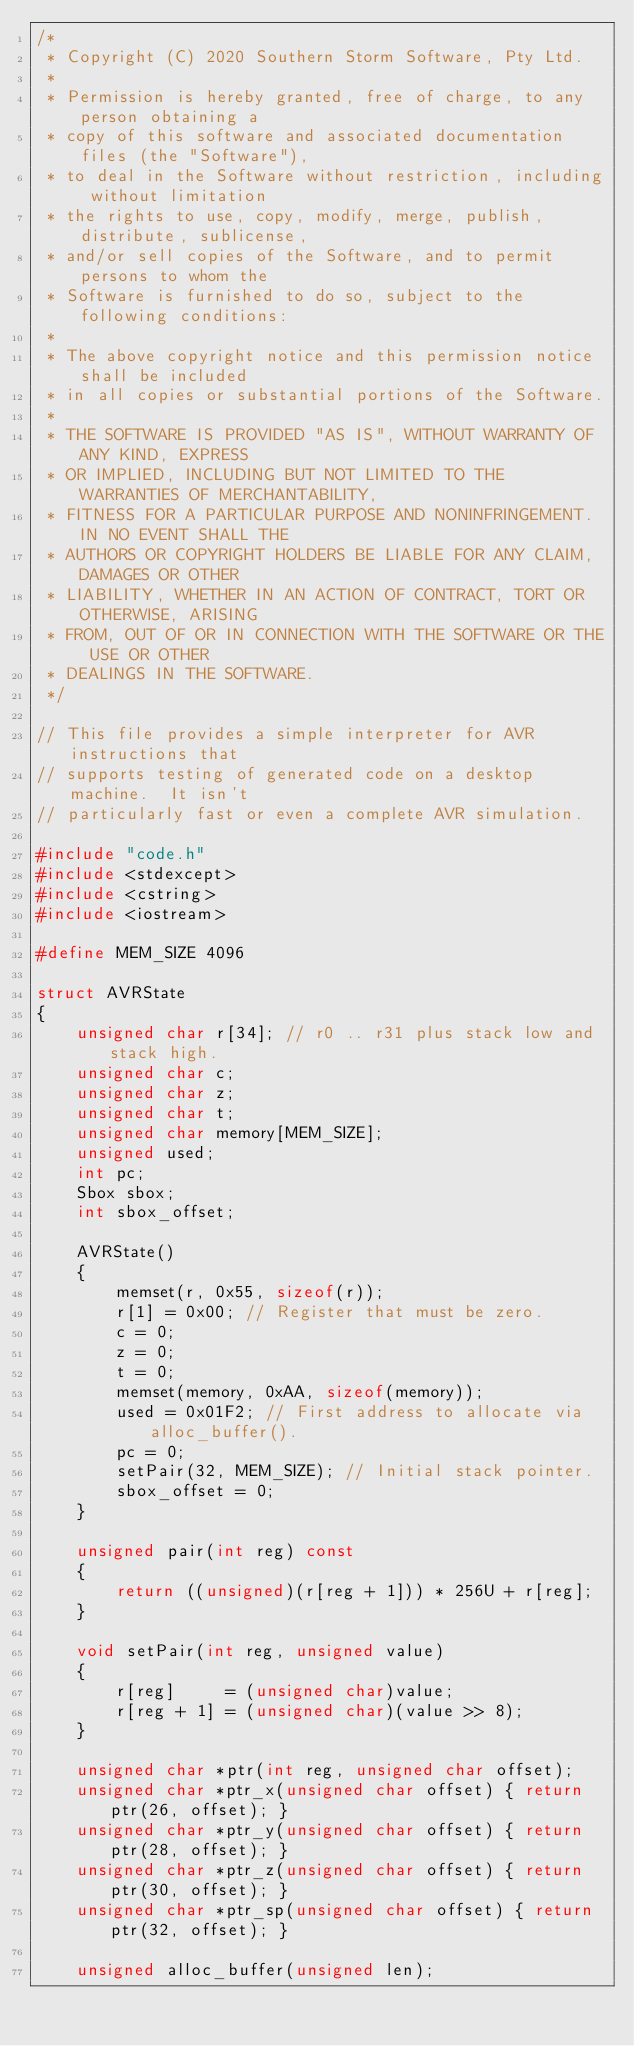<code> <loc_0><loc_0><loc_500><loc_500><_C++_>/*
 * Copyright (C) 2020 Southern Storm Software, Pty Ltd.
 *
 * Permission is hereby granted, free of charge, to any person obtaining a
 * copy of this software and associated documentation files (the "Software"),
 * to deal in the Software without restriction, including without limitation
 * the rights to use, copy, modify, merge, publish, distribute, sublicense,
 * and/or sell copies of the Software, and to permit persons to whom the
 * Software is furnished to do so, subject to the following conditions:
 *
 * The above copyright notice and this permission notice shall be included
 * in all copies or substantial portions of the Software.
 *
 * THE SOFTWARE IS PROVIDED "AS IS", WITHOUT WARRANTY OF ANY KIND, EXPRESS
 * OR IMPLIED, INCLUDING BUT NOT LIMITED TO THE WARRANTIES OF MERCHANTABILITY,
 * FITNESS FOR A PARTICULAR PURPOSE AND NONINFRINGEMENT. IN NO EVENT SHALL THE
 * AUTHORS OR COPYRIGHT HOLDERS BE LIABLE FOR ANY CLAIM, DAMAGES OR OTHER
 * LIABILITY, WHETHER IN AN ACTION OF CONTRACT, TORT OR OTHERWISE, ARISING
 * FROM, OUT OF OR IN CONNECTION WITH THE SOFTWARE OR THE USE OR OTHER
 * DEALINGS IN THE SOFTWARE.
 */

// This file provides a simple interpreter for AVR instructions that
// supports testing of generated code on a desktop machine.  It isn't
// particularly fast or even a complete AVR simulation.

#include "code.h"
#include <stdexcept>
#include <cstring>
#include <iostream>

#define MEM_SIZE 4096

struct AVRState
{
    unsigned char r[34]; // r0 .. r31 plus stack low and stack high.
    unsigned char c;
    unsigned char z;
    unsigned char t;
    unsigned char memory[MEM_SIZE];
    unsigned used;
    int pc;
    Sbox sbox;
    int sbox_offset;

    AVRState()
    {
        memset(r, 0x55, sizeof(r));
        r[1] = 0x00; // Register that must be zero.
        c = 0;
        z = 0;
        t = 0;
        memset(memory, 0xAA, sizeof(memory));
        used = 0x01F2; // First address to allocate via alloc_buffer().
        pc = 0;
        setPair(32, MEM_SIZE); // Initial stack pointer.
        sbox_offset = 0;
    }

    unsigned pair(int reg) const
    {
        return ((unsigned)(r[reg + 1])) * 256U + r[reg];
    }

    void setPair(int reg, unsigned value)
    {
        r[reg]     = (unsigned char)value;
        r[reg + 1] = (unsigned char)(value >> 8);
    }

    unsigned char *ptr(int reg, unsigned char offset);
    unsigned char *ptr_x(unsigned char offset) { return ptr(26, offset); }
    unsigned char *ptr_y(unsigned char offset) { return ptr(28, offset); }
    unsigned char *ptr_z(unsigned char offset) { return ptr(30, offset); }
    unsigned char *ptr_sp(unsigned char offset) { return ptr(32, offset); }

    unsigned alloc_buffer(unsigned len);</code> 